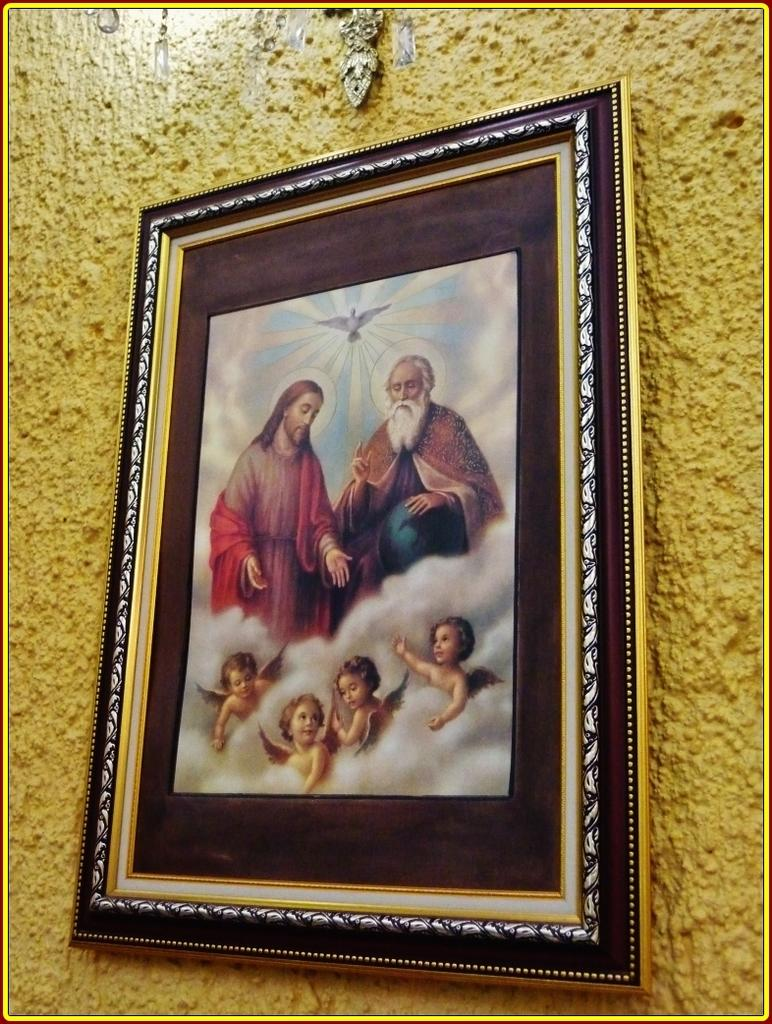What is depicted in the photo frame in the image? There is a Jesus photo frame in the image. Where is the photo frame located? The photo frame is hanging on a wall. What color is the wall on which the photo frame is hanging? The wall is yellow in color. How many ants are crawling on the wall in the image? There are no ants visible in the image; the focus is on the Jesus photo frame and the yellow wall. 